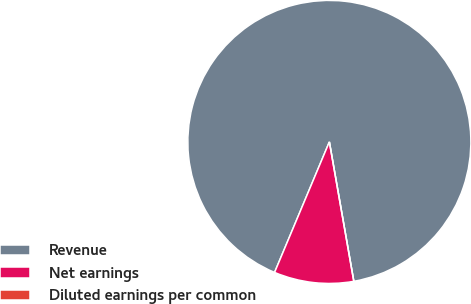<chart> <loc_0><loc_0><loc_500><loc_500><pie_chart><fcel>Revenue<fcel>Net earnings<fcel>Diluted earnings per common<nl><fcel>90.91%<fcel>9.09%<fcel>0.0%<nl></chart> 